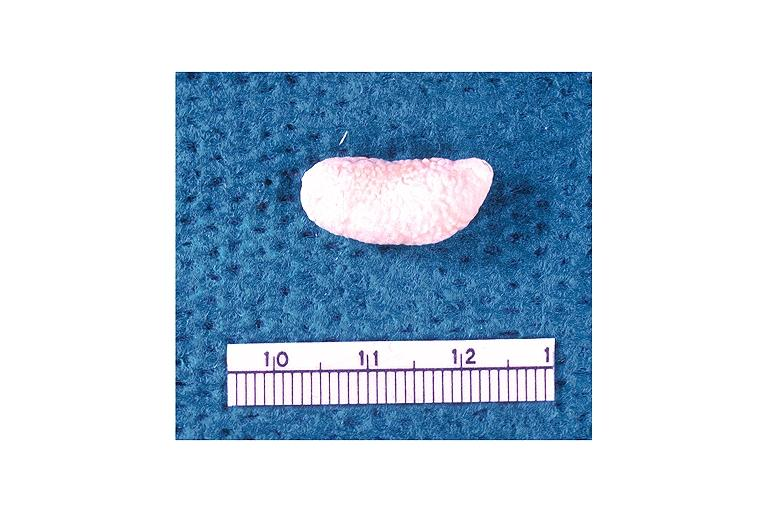s oral present?
Answer the question using a single word or phrase. Yes 